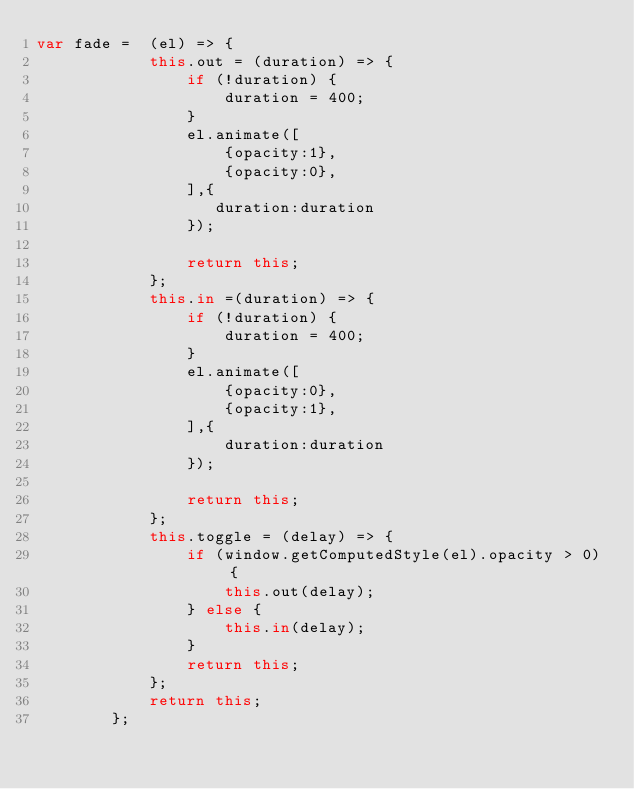<code> <loc_0><loc_0><loc_500><loc_500><_JavaScript_>var fade =  (el) => {
            this.out = (duration) => {
                if (!duration) {
                    duration = 400;
                }
                el.animate([
                    {opacity:1},
                    {opacity:0},
                ],{
                   duration:duration
                });

                return this;
            };
            this.in =(duration) => {
                if (!duration) {
                    duration = 400;
                }
                el.animate([
                    {opacity:0},
                    {opacity:1},
                ],{
                    duration:duration
                });

                return this;
            };
            this.toggle = (delay) => {
                if (window.getComputedStyle(el).opacity > 0) {
                    this.out(delay);
                } else {
                    this.in(delay);
                }
                return this;
            };
            return this;
        };
</code> 